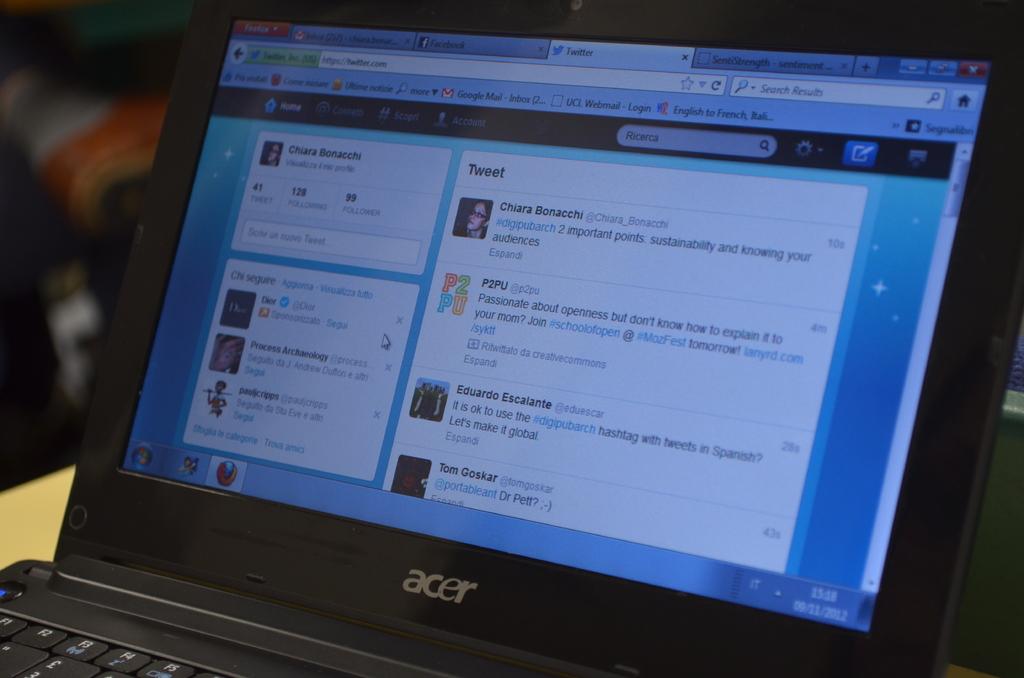What's chiara's last name?
Your answer should be compact. Bonacchi. What type of laptop is this?
Your answer should be compact. Acer. 